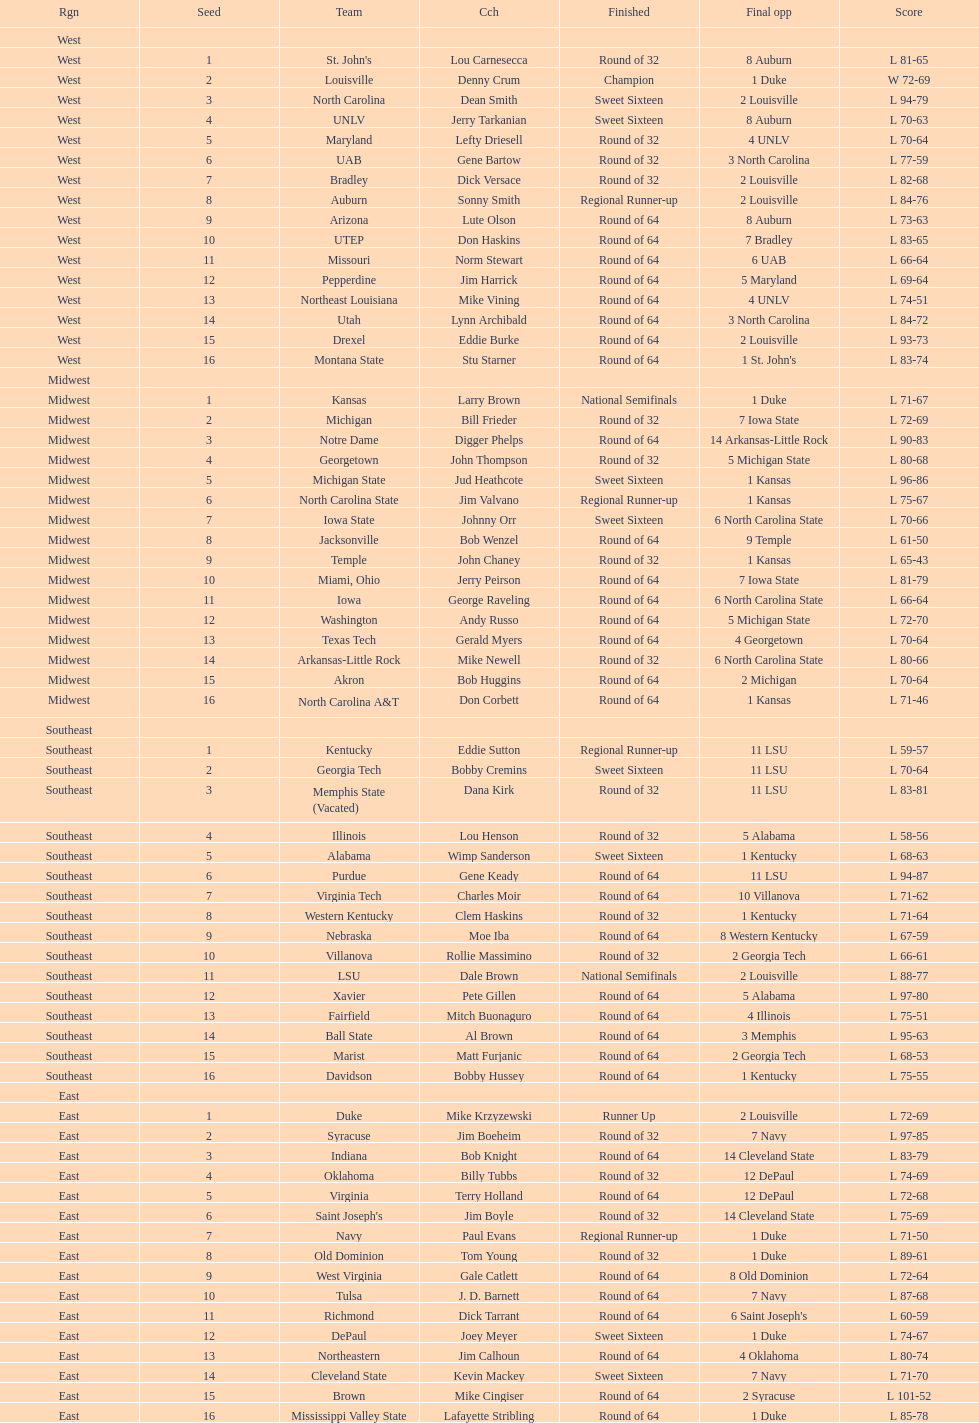Which team went finished later in the tournament, st. john's or north carolina a&t? North Carolina A&T. 